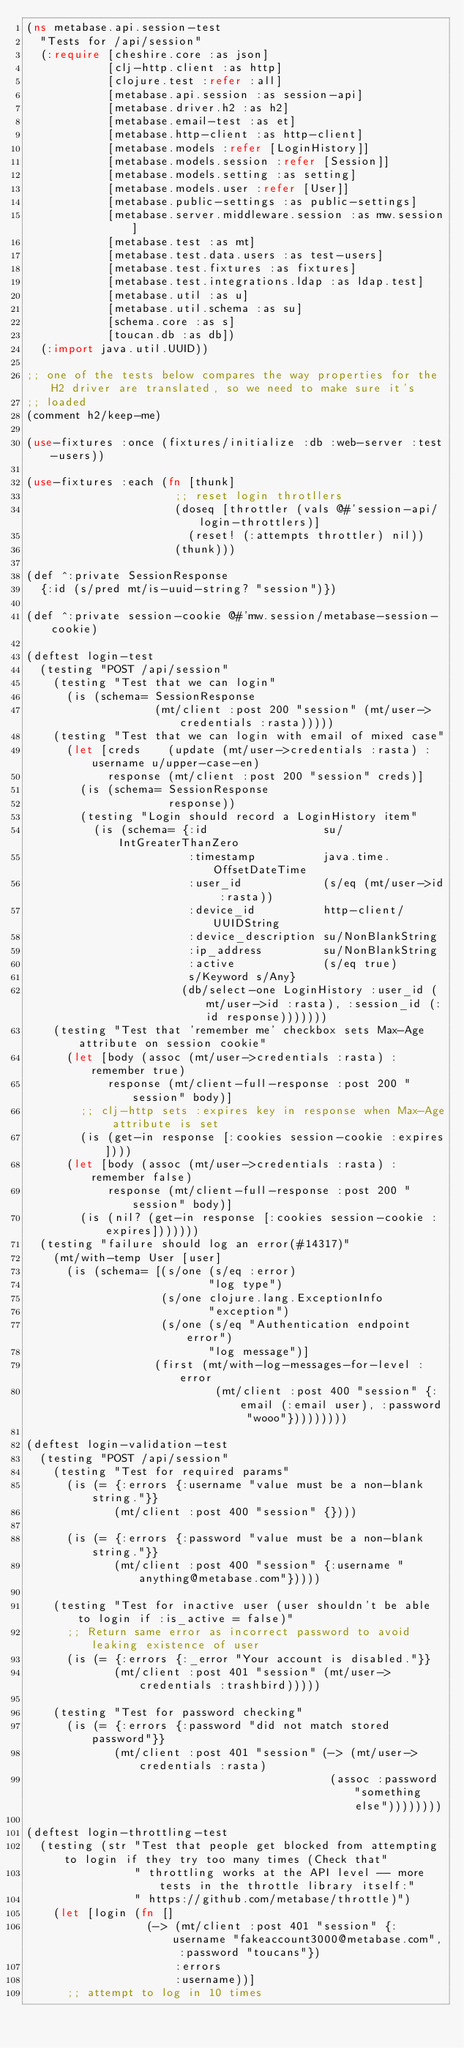Convert code to text. <code><loc_0><loc_0><loc_500><loc_500><_Clojure_>(ns metabase.api.session-test
  "Tests for /api/session"
  (:require [cheshire.core :as json]
            [clj-http.client :as http]
            [clojure.test :refer :all]
            [metabase.api.session :as session-api]
            [metabase.driver.h2 :as h2]
            [metabase.email-test :as et]
            [metabase.http-client :as http-client]
            [metabase.models :refer [LoginHistory]]
            [metabase.models.session :refer [Session]]
            [metabase.models.setting :as setting]
            [metabase.models.user :refer [User]]
            [metabase.public-settings :as public-settings]
            [metabase.server.middleware.session :as mw.session]
            [metabase.test :as mt]
            [metabase.test.data.users :as test-users]
            [metabase.test.fixtures :as fixtures]
            [metabase.test.integrations.ldap :as ldap.test]
            [metabase.util :as u]
            [metabase.util.schema :as su]
            [schema.core :as s]
            [toucan.db :as db])
  (:import java.util.UUID))

;; one of the tests below compares the way properties for the H2 driver are translated, so we need to make sure it's
;; loaded
(comment h2/keep-me)

(use-fixtures :once (fixtures/initialize :db :web-server :test-users))

(use-fixtures :each (fn [thunk]
                      ;; reset login throtllers
                      (doseq [throttler (vals @#'session-api/login-throttlers)]
                        (reset! (:attempts throttler) nil))
                      (thunk)))

(def ^:private SessionResponse
  {:id (s/pred mt/is-uuid-string? "session")})

(def ^:private session-cookie @#'mw.session/metabase-session-cookie)

(deftest login-test
  (testing "POST /api/session"
    (testing "Test that we can login"
      (is (schema= SessionResponse
                   (mt/client :post 200 "session" (mt/user->credentials :rasta)))))
    (testing "Test that we can login with email of mixed case"
      (let [creds    (update (mt/user->credentials :rasta) :username u/upper-case-en)
            response (mt/client :post 200 "session" creds)]
        (is (schema= SessionResponse
                     response))
        (testing "Login should record a LoginHistory item"
          (is (schema= {:id                 su/IntGreaterThanZero
                        :timestamp          java.time.OffsetDateTime
                        :user_id            (s/eq (mt/user->id :rasta))
                        :device_id          http-client/UUIDString
                        :device_description su/NonBlankString
                        :ip_address         su/NonBlankString
                        :active             (s/eq true)
                        s/Keyword s/Any}
                       (db/select-one LoginHistory :user_id (mt/user->id :rasta), :session_id (:id response)))))))
    (testing "Test that 'remember me' checkbox sets Max-Age attribute on session cookie"
      (let [body (assoc (mt/user->credentials :rasta) :remember true)
            response (mt/client-full-response :post 200 "session" body)]
        ;; clj-http sets :expires key in response when Max-Age attribute is set
        (is (get-in response [:cookies session-cookie :expires])))
      (let [body (assoc (mt/user->credentials :rasta) :remember false)
            response (mt/client-full-response :post 200 "session" body)]
        (is (nil? (get-in response [:cookies session-cookie :expires]))))))
  (testing "failure should log an error(#14317)"
    (mt/with-temp User [user]
      (is (schema= [(s/one (s/eq :error)
                           "log type")
                    (s/one clojure.lang.ExceptionInfo
                           "exception")
                    (s/one (s/eq "Authentication endpoint error")
                           "log message")]
                   (first (mt/with-log-messages-for-level :error
                            (mt/client :post 400 "session" {:email (:email user), :password "wooo"}))))))))

(deftest login-validation-test
  (testing "POST /api/session"
    (testing "Test for required params"
      (is (= {:errors {:username "value must be a non-blank string."}}
             (mt/client :post 400 "session" {})))

      (is (= {:errors {:password "value must be a non-blank string."}}
             (mt/client :post 400 "session" {:username "anything@metabase.com"}))))

    (testing "Test for inactive user (user shouldn't be able to login if :is_active = false)"
      ;; Return same error as incorrect password to avoid leaking existence of user
      (is (= {:errors {:_error "Your account is disabled."}}
             (mt/client :post 401 "session" (mt/user->credentials :trashbird)))))

    (testing "Test for password checking"
      (is (= {:errors {:password "did not match stored password"}}
             (mt/client :post 401 "session" (-> (mt/user->credentials :rasta)
                                             (assoc :password "something else"))))))))

(deftest login-throttling-test
  (testing (str "Test that people get blocked from attempting to login if they try too many times (Check that"
                " throttling works at the API level -- more tests in the throttle library itself:"
                " https://github.com/metabase/throttle)")
    (let [login (fn []
                  (-> (mt/client :post 401 "session" {:username "fakeaccount3000@metabase.com", :password "toucans"})
                      :errors
                      :username))]
      ;; attempt to log in 10 times</code> 